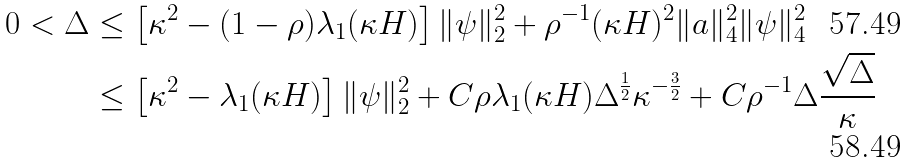<formula> <loc_0><loc_0><loc_500><loc_500>0 < \Delta & \leq \left [ \kappa ^ { 2 } - ( 1 - \rho ) \lambda _ { 1 } ( \kappa H ) \right ] \| \psi \| _ { 2 } ^ { 2 } + \rho ^ { - 1 } ( \kappa H ) ^ { 2 } \| { a } \| _ { 4 } ^ { 2 } \| \psi \| _ { 4 } ^ { 2 } \\ & \leq \left [ \kappa ^ { 2 } - \lambda _ { 1 } ( \kappa H ) \right ] \| \psi \| _ { 2 } ^ { 2 } + C \rho \lambda _ { 1 } ( \kappa H ) \Delta ^ { \frac { 1 } { 2 } } \kappa ^ { - \frac { 3 } { 2 } } + C \rho ^ { - 1 } \Delta \frac { \sqrt { \Delta } } { \kappa }</formula> 